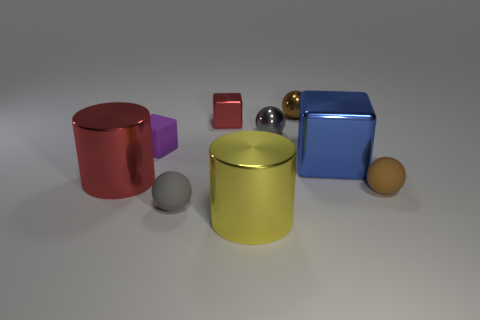What is the color of the large object to the left of the red shiny thing that is behind the gray metallic object?
Your answer should be very brief. Red. There is a gray object that is to the right of the large yellow metal cylinder; does it have the same shape as the large metallic thing that is left of the small gray rubber thing?
Make the answer very short. No. What shape is the red metallic thing that is the same size as the purple rubber object?
Your response must be concise. Cube. What color is the large cube that is the same material as the tiny red cube?
Keep it short and to the point. Blue. There is a brown rubber thing; does it have the same shape as the small brown object behind the brown rubber object?
Ensure brevity in your answer.  Yes. There is a big cylinder that is the same color as the small metallic cube; what is its material?
Provide a succinct answer. Metal. There is another brown sphere that is the same size as the brown shiny sphere; what is its material?
Your response must be concise. Rubber. Is there a object of the same color as the tiny rubber block?
Offer a very short reply. No. The thing that is both behind the big red cylinder and in front of the small purple matte cube has what shape?
Make the answer very short. Cube. How many big red cylinders have the same material as the yellow cylinder?
Ensure brevity in your answer.  1. 